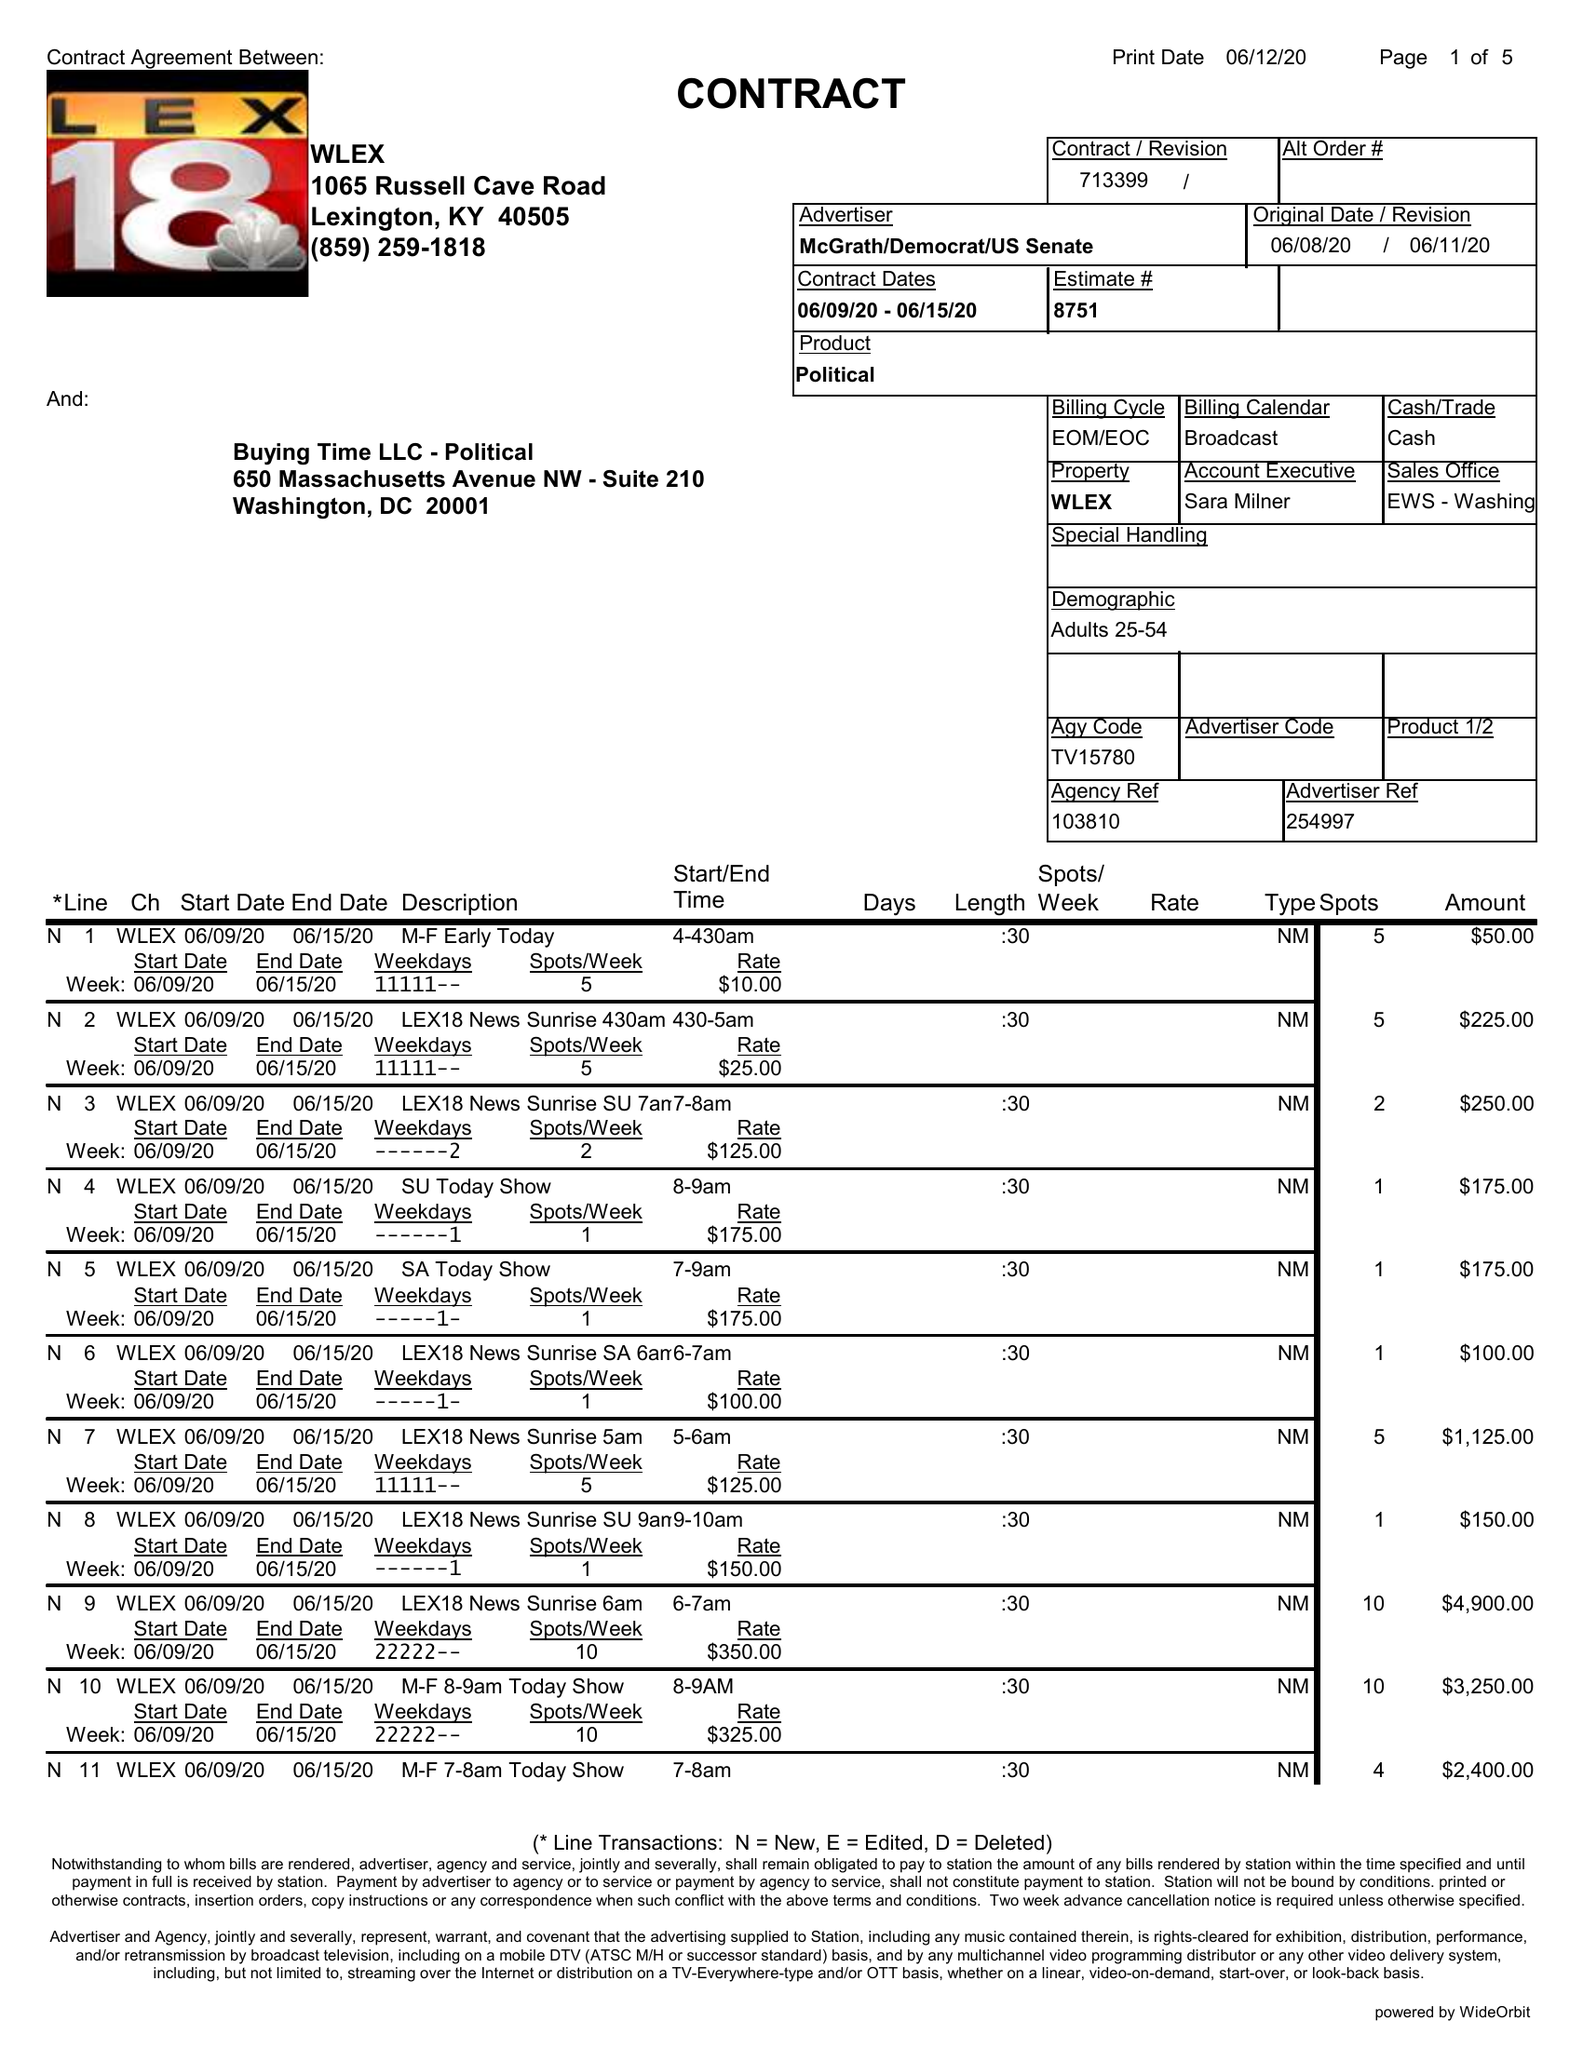What is the value for the flight_to?
Answer the question using a single word or phrase. 06/15/20 